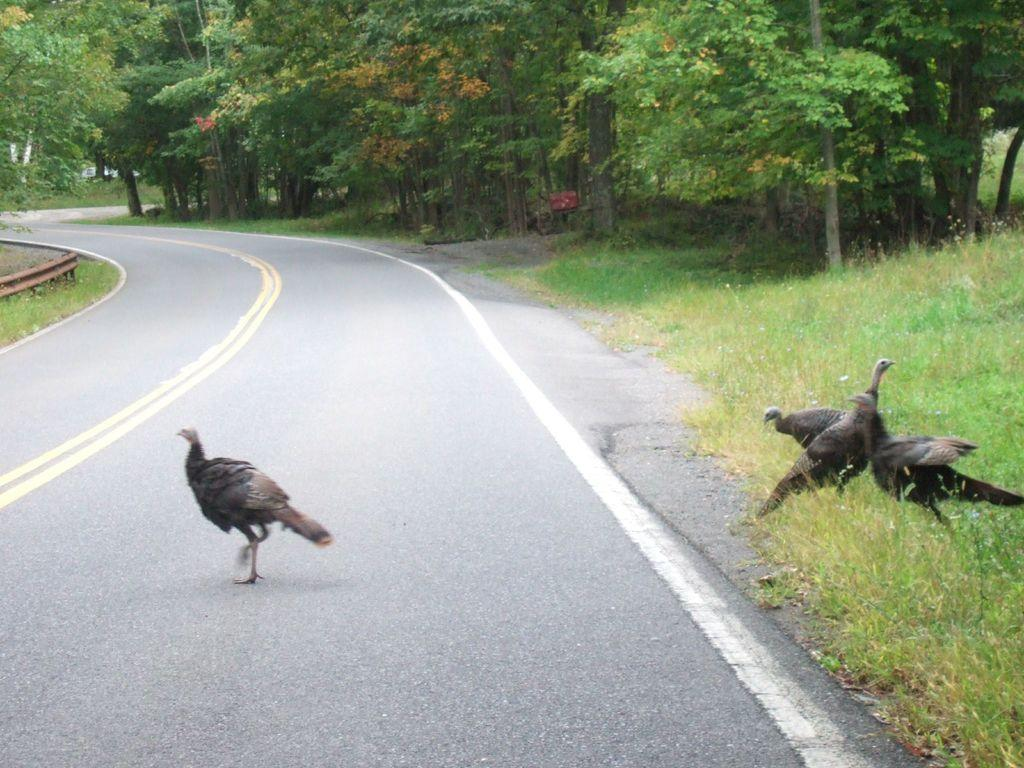What type of animals can be seen in the image? There are birds in the image. What type of vegetation is present in the image? There is grass in the image. What man-made structure can be seen in the image? There is a road in the image. What type of natural feature is present in the image? There are trees in the image. What type of account does the bird have in the image? There is no mention of an account in the image; it features birds, grass, a road, and trees. 